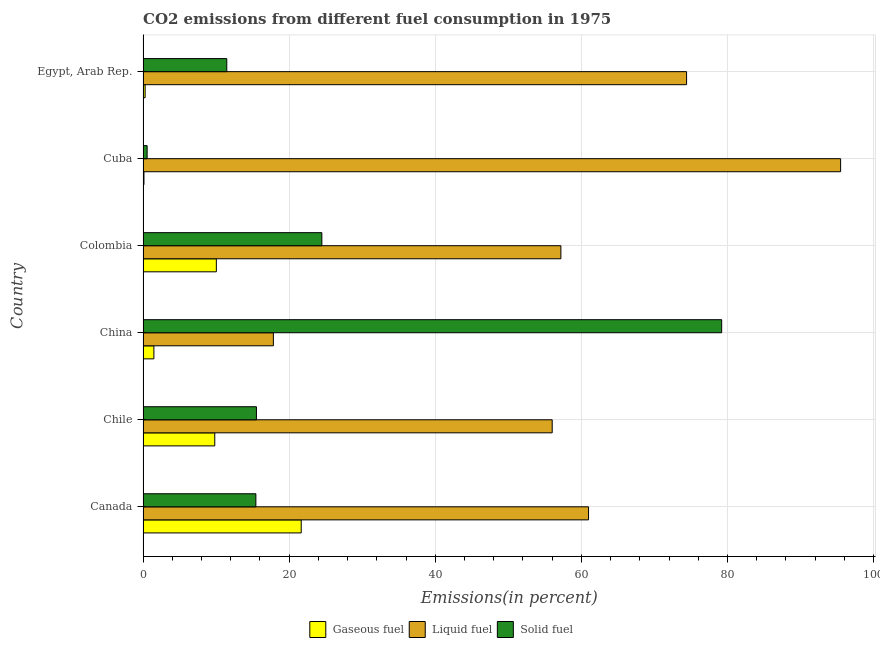How many different coloured bars are there?
Your answer should be compact. 3. How many bars are there on the 4th tick from the top?
Make the answer very short. 3. How many bars are there on the 5th tick from the bottom?
Your answer should be very brief. 3. What is the label of the 5th group of bars from the top?
Keep it short and to the point. Chile. What is the percentage of solid fuel emission in Cuba?
Your answer should be compact. 0.56. Across all countries, what is the maximum percentage of solid fuel emission?
Offer a terse response. 79.21. Across all countries, what is the minimum percentage of solid fuel emission?
Your answer should be compact. 0.56. In which country was the percentage of liquid fuel emission maximum?
Keep it short and to the point. Cuba. What is the total percentage of solid fuel emission in the graph?
Offer a terse response. 146.66. What is the difference between the percentage of liquid fuel emission in Chile and that in Colombia?
Offer a terse response. -1.19. What is the difference between the percentage of liquid fuel emission in Colombia and the percentage of gaseous fuel emission in China?
Your answer should be very brief. 55.71. What is the average percentage of liquid fuel emission per country?
Your answer should be very brief. 60.32. What is the difference between the percentage of gaseous fuel emission and percentage of solid fuel emission in Canada?
Offer a terse response. 6.21. In how many countries, is the percentage of gaseous fuel emission greater than 68 %?
Offer a very short reply. 0. What is the ratio of the percentage of liquid fuel emission in Canada to that in Cuba?
Provide a short and direct response. 0.64. Is the percentage of liquid fuel emission in Canada less than that in Colombia?
Your response must be concise. No. Is the difference between the percentage of gaseous fuel emission in China and Cuba greater than the difference between the percentage of liquid fuel emission in China and Cuba?
Ensure brevity in your answer.  Yes. What is the difference between the highest and the second highest percentage of liquid fuel emission?
Provide a succinct answer. 21.09. What is the difference between the highest and the lowest percentage of liquid fuel emission?
Give a very brief answer. 77.65. Is the sum of the percentage of gaseous fuel emission in Canada and Chile greater than the maximum percentage of solid fuel emission across all countries?
Give a very brief answer. No. What does the 3rd bar from the top in Colombia represents?
Give a very brief answer. Gaseous fuel. What does the 1st bar from the bottom in Chile represents?
Keep it short and to the point. Gaseous fuel. Is it the case that in every country, the sum of the percentage of gaseous fuel emission and percentage of liquid fuel emission is greater than the percentage of solid fuel emission?
Offer a terse response. No. How many countries are there in the graph?
Provide a short and direct response. 6. What is the difference between two consecutive major ticks on the X-axis?
Provide a succinct answer. 20. Are the values on the major ticks of X-axis written in scientific E-notation?
Offer a very short reply. No. Does the graph contain any zero values?
Your response must be concise. No. Does the graph contain grids?
Provide a short and direct response. Yes. How are the legend labels stacked?
Make the answer very short. Horizontal. What is the title of the graph?
Provide a short and direct response. CO2 emissions from different fuel consumption in 1975. What is the label or title of the X-axis?
Make the answer very short. Emissions(in percent). What is the Emissions(in percent) in Gaseous fuel in Canada?
Ensure brevity in your answer.  21.65. What is the Emissions(in percent) of Liquid fuel in Canada?
Offer a terse response. 60.98. What is the Emissions(in percent) of Solid fuel in Canada?
Your response must be concise. 15.44. What is the Emissions(in percent) in Gaseous fuel in Chile?
Make the answer very short. 9.82. What is the Emissions(in percent) in Liquid fuel in Chile?
Make the answer very short. 56.01. What is the Emissions(in percent) of Solid fuel in Chile?
Provide a succinct answer. 15.52. What is the Emissions(in percent) in Gaseous fuel in China?
Your answer should be compact. 1.48. What is the Emissions(in percent) of Liquid fuel in China?
Offer a very short reply. 17.84. What is the Emissions(in percent) of Solid fuel in China?
Provide a short and direct response. 79.21. What is the Emissions(in percent) in Gaseous fuel in Colombia?
Your response must be concise. 10.03. What is the Emissions(in percent) in Liquid fuel in Colombia?
Provide a succinct answer. 57.2. What is the Emissions(in percent) of Solid fuel in Colombia?
Your response must be concise. 24.48. What is the Emissions(in percent) of Gaseous fuel in Cuba?
Provide a short and direct response. 0.12. What is the Emissions(in percent) in Liquid fuel in Cuba?
Provide a succinct answer. 95.49. What is the Emissions(in percent) of Solid fuel in Cuba?
Ensure brevity in your answer.  0.56. What is the Emissions(in percent) in Gaseous fuel in Egypt, Arab Rep.?
Your answer should be very brief. 0.28. What is the Emissions(in percent) in Liquid fuel in Egypt, Arab Rep.?
Ensure brevity in your answer.  74.4. What is the Emissions(in percent) of Solid fuel in Egypt, Arab Rep.?
Your response must be concise. 11.46. Across all countries, what is the maximum Emissions(in percent) in Gaseous fuel?
Provide a succinct answer. 21.65. Across all countries, what is the maximum Emissions(in percent) of Liquid fuel?
Offer a terse response. 95.49. Across all countries, what is the maximum Emissions(in percent) of Solid fuel?
Offer a terse response. 79.21. Across all countries, what is the minimum Emissions(in percent) of Gaseous fuel?
Offer a very short reply. 0.12. Across all countries, what is the minimum Emissions(in percent) of Liquid fuel?
Your response must be concise. 17.84. Across all countries, what is the minimum Emissions(in percent) in Solid fuel?
Make the answer very short. 0.56. What is the total Emissions(in percent) in Gaseous fuel in the graph?
Make the answer very short. 43.38. What is the total Emissions(in percent) of Liquid fuel in the graph?
Your response must be concise. 361.91. What is the total Emissions(in percent) of Solid fuel in the graph?
Offer a terse response. 146.66. What is the difference between the Emissions(in percent) in Gaseous fuel in Canada and that in Chile?
Keep it short and to the point. 11.84. What is the difference between the Emissions(in percent) in Liquid fuel in Canada and that in Chile?
Provide a succinct answer. 4.97. What is the difference between the Emissions(in percent) of Solid fuel in Canada and that in Chile?
Make the answer very short. -0.08. What is the difference between the Emissions(in percent) in Gaseous fuel in Canada and that in China?
Your response must be concise. 20.17. What is the difference between the Emissions(in percent) in Liquid fuel in Canada and that in China?
Your answer should be very brief. 43.14. What is the difference between the Emissions(in percent) in Solid fuel in Canada and that in China?
Ensure brevity in your answer.  -63.76. What is the difference between the Emissions(in percent) of Gaseous fuel in Canada and that in Colombia?
Your answer should be very brief. 11.62. What is the difference between the Emissions(in percent) in Liquid fuel in Canada and that in Colombia?
Offer a very short reply. 3.78. What is the difference between the Emissions(in percent) of Solid fuel in Canada and that in Colombia?
Give a very brief answer. -9.03. What is the difference between the Emissions(in percent) in Gaseous fuel in Canada and that in Cuba?
Give a very brief answer. 21.53. What is the difference between the Emissions(in percent) of Liquid fuel in Canada and that in Cuba?
Offer a terse response. -34.51. What is the difference between the Emissions(in percent) of Solid fuel in Canada and that in Cuba?
Offer a terse response. 14.89. What is the difference between the Emissions(in percent) in Gaseous fuel in Canada and that in Egypt, Arab Rep.?
Give a very brief answer. 21.37. What is the difference between the Emissions(in percent) of Liquid fuel in Canada and that in Egypt, Arab Rep.?
Ensure brevity in your answer.  -13.42. What is the difference between the Emissions(in percent) of Solid fuel in Canada and that in Egypt, Arab Rep.?
Give a very brief answer. 3.98. What is the difference between the Emissions(in percent) of Gaseous fuel in Chile and that in China?
Keep it short and to the point. 8.33. What is the difference between the Emissions(in percent) of Liquid fuel in Chile and that in China?
Make the answer very short. 38.17. What is the difference between the Emissions(in percent) of Solid fuel in Chile and that in China?
Provide a succinct answer. -63.69. What is the difference between the Emissions(in percent) of Gaseous fuel in Chile and that in Colombia?
Keep it short and to the point. -0.22. What is the difference between the Emissions(in percent) of Liquid fuel in Chile and that in Colombia?
Offer a terse response. -1.19. What is the difference between the Emissions(in percent) in Solid fuel in Chile and that in Colombia?
Make the answer very short. -8.96. What is the difference between the Emissions(in percent) in Gaseous fuel in Chile and that in Cuba?
Keep it short and to the point. 9.69. What is the difference between the Emissions(in percent) of Liquid fuel in Chile and that in Cuba?
Your response must be concise. -39.48. What is the difference between the Emissions(in percent) of Solid fuel in Chile and that in Cuba?
Your answer should be very brief. 14.96. What is the difference between the Emissions(in percent) of Gaseous fuel in Chile and that in Egypt, Arab Rep.?
Your answer should be very brief. 9.53. What is the difference between the Emissions(in percent) of Liquid fuel in Chile and that in Egypt, Arab Rep.?
Offer a very short reply. -18.39. What is the difference between the Emissions(in percent) in Solid fuel in Chile and that in Egypt, Arab Rep.?
Offer a very short reply. 4.06. What is the difference between the Emissions(in percent) in Gaseous fuel in China and that in Colombia?
Your answer should be very brief. -8.55. What is the difference between the Emissions(in percent) in Liquid fuel in China and that in Colombia?
Provide a short and direct response. -39.36. What is the difference between the Emissions(in percent) in Solid fuel in China and that in Colombia?
Your response must be concise. 54.73. What is the difference between the Emissions(in percent) of Gaseous fuel in China and that in Cuba?
Your response must be concise. 1.36. What is the difference between the Emissions(in percent) in Liquid fuel in China and that in Cuba?
Your response must be concise. -77.65. What is the difference between the Emissions(in percent) of Solid fuel in China and that in Cuba?
Your answer should be compact. 78.65. What is the difference between the Emissions(in percent) in Gaseous fuel in China and that in Egypt, Arab Rep.?
Provide a short and direct response. 1.2. What is the difference between the Emissions(in percent) of Liquid fuel in China and that in Egypt, Arab Rep.?
Give a very brief answer. -56.56. What is the difference between the Emissions(in percent) in Solid fuel in China and that in Egypt, Arab Rep.?
Make the answer very short. 67.74. What is the difference between the Emissions(in percent) of Gaseous fuel in Colombia and that in Cuba?
Ensure brevity in your answer.  9.91. What is the difference between the Emissions(in percent) of Liquid fuel in Colombia and that in Cuba?
Offer a very short reply. -38.29. What is the difference between the Emissions(in percent) of Solid fuel in Colombia and that in Cuba?
Make the answer very short. 23.92. What is the difference between the Emissions(in percent) in Gaseous fuel in Colombia and that in Egypt, Arab Rep.?
Your answer should be very brief. 9.75. What is the difference between the Emissions(in percent) in Liquid fuel in Colombia and that in Egypt, Arab Rep.?
Offer a very short reply. -17.2. What is the difference between the Emissions(in percent) of Solid fuel in Colombia and that in Egypt, Arab Rep.?
Keep it short and to the point. 13.02. What is the difference between the Emissions(in percent) in Gaseous fuel in Cuba and that in Egypt, Arab Rep.?
Provide a succinct answer. -0.16. What is the difference between the Emissions(in percent) in Liquid fuel in Cuba and that in Egypt, Arab Rep.?
Offer a very short reply. 21.09. What is the difference between the Emissions(in percent) of Solid fuel in Cuba and that in Egypt, Arab Rep.?
Your answer should be very brief. -10.91. What is the difference between the Emissions(in percent) in Gaseous fuel in Canada and the Emissions(in percent) in Liquid fuel in Chile?
Ensure brevity in your answer.  -34.36. What is the difference between the Emissions(in percent) of Gaseous fuel in Canada and the Emissions(in percent) of Solid fuel in Chile?
Ensure brevity in your answer.  6.13. What is the difference between the Emissions(in percent) of Liquid fuel in Canada and the Emissions(in percent) of Solid fuel in Chile?
Offer a very short reply. 45.46. What is the difference between the Emissions(in percent) of Gaseous fuel in Canada and the Emissions(in percent) of Liquid fuel in China?
Your response must be concise. 3.81. What is the difference between the Emissions(in percent) in Gaseous fuel in Canada and the Emissions(in percent) in Solid fuel in China?
Offer a very short reply. -57.55. What is the difference between the Emissions(in percent) in Liquid fuel in Canada and the Emissions(in percent) in Solid fuel in China?
Provide a short and direct response. -18.22. What is the difference between the Emissions(in percent) in Gaseous fuel in Canada and the Emissions(in percent) in Liquid fuel in Colombia?
Your answer should be very brief. -35.55. What is the difference between the Emissions(in percent) of Gaseous fuel in Canada and the Emissions(in percent) of Solid fuel in Colombia?
Provide a short and direct response. -2.83. What is the difference between the Emissions(in percent) of Liquid fuel in Canada and the Emissions(in percent) of Solid fuel in Colombia?
Your response must be concise. 36.5. What is the difference between the Emissions(in percent) in Gaseous fuel in Canada and the Emissions(in percent) in Liquid fuel in Cuba?
Keep it short and to the point. -73.84. What is the difference between the Emissions(in percent) of Gaseous fuel in Canada and the Emissions(in percent) of Solid fuel in Cuba?
Give a very brief answer. 21.1. What is the difference between the Emissions(in percent) in Liquid fuel in Canada and the Emissions(in percent) in Solid fuel in Cuba?
Offer a terse response. 60.43. What is the difference between the Emissions(in percent) of Gaseous fuel in Canada and the Emissions(in percent) of Liquid fuel in Egypt, Arab Rep.?
Provide a short and direct response. -52.75. What is the difference between the Emissions(in percent) of Gaseous fuel in Canada and the Emissions(in percent) of Solid fuel in Egypt, Arab Rep.?
Make the answer very short. 10.19. What is the difference between the Emissions(in percent) of Liquid fuel in Canada and the Emissions(in percent) of Solid fuel in Egypt, Arab Rep.?
Keep it short and to the point. 49.52. What is the difference between the Emissions(in percent) in Gaseous fuel in Chile and the Emissions(in percent) in Liquid fuel in China?
Your answer should be compact. -8.02. What is the difference between the Emissions(in percent) of Gaseous fuel in Chile and the Emissions(in percent) of Solid fuel in China?
Your answer should be compact. -69.39. What is the difference between the Emissions(in percent) in Liquid fuel in Chile and the Emissions(in percent) in Solid fuel in China?
Offer a terse response. -23.2. What is the difference between the Emissions(in percent) in Gaseous fuel in Chile and the Emissions(in percent) in Liquid fuel in Colombia?
Keep it short and to the point. -47.38. What is the difference between the Emissions(in percent) in Gaseous fuel in Chile and the Emissions(in percent) in Solid fuel in Colombia?
Make the answer very short. -14.66. What is the difference between the Emissions(in percent) of Liquid fuel in Chile and the Emissions(in percent) of Solid fuel in Colombia?
Make the answer very short. 31.53. What is the difference between the Emissions(in percent) of Gaseous fuel in Chile and the Emissions(in percent) of Liquid fuel in Cuba?
Ensure brevity in your answer.  -85.67. What is the difference between the Emissions(in percent) of Gaseous fuel in Chile and the Emissions(in percent) of Solid fuel in Cuba?
Provide a short and direct response. 9.26. What is the difference between the Emissions(in percent) in Liquid fuel in Chile and the Emissions(in percent) in Solid fuel in Cuba?
Offer a terse response. 55.45. What is the difference between the Emissions(in percent) in Gaseous fuel in Chile and the Emissions(in percent) in Liquid fuel in Egypt, Arab Rep.?
Ensure brevity in your answer.  -64.59. What is the difference between the Emissions(in percent) of Gaseous fuel in Chile and the Emissions(in percent) of Solid fuel in Egypt, Arab Rep.?
Keep it short and to the point. -1.65. What is the difference between the Emissions(in percent) of Liquid fuel in Chile and the Emissions(in percent) of Solid fuel in Egypt, Arab Rep.?
Provide a short and direct response. 44.55. What is the difference between the Emissions(in percent) of Gaseous fuel in China and the Emissions(in percent) of Liquid fuel in Colombia?
Ensure brevity in your answer.  -55.71. What is the difference between the Emissions(in percent) of Gaseous fuel in China and the Emissions(in percent) of Solid fuel in Colombia?
Keep it short and to the point. -22.99. What is the difference between the Emissions(in percent) in Liquid fuel in China and the Emissions(in percent) in Solid fuel in Colombia?
Make the answer very short. -6.64. What is the difference between the Emissions(in percent) of Gaseous fuel in China and the Emissions(in percent) of Liquid fuel in Cuba?
Your response must be concise. -94.01. What is the difference between the Emissions(in percent) of Gaseous fuel in China and the Emissions(in percent) of Solid fuel in Cuba?
Provide a short and direct response. 0.93. What is the difference between the Emissions(in percent) in Liquid fuel in China and the Emissions(in percent) in Solid fuel in Cuba?
Your answer should be compact. 17.28. What is the difference between the Emissions(in percent) in Gaseous fuel in China and the Emissions(in percent) in Liquid fuel in Egypt, Arab Rep.?
Keep it short and to the point. -72.92. What is the difference between the Emissions(in percent) in Gaseous fuel in China and the Emissions(in percent) in Solid fuel in Egypt, Arab Rep.?
Ensure brevity in your answer.  -9.98. What is the difference between the Emissions(in percent) of Liquid fuel in China and the Emissions(in percent) of Solid fuel in Egypt, Arab Rep.?
Your response must be concise. 6.38. What is the difference between the Emissions(in percent) of Gaseous fuel in Colombia and the Emissions(in percent) of Liquid fuel in Cuba?
Your answer should be very brief. -85.46. What is the difference between the Emissions(in percent) in Gaseous fuel in Colombia and the Emissions(in percent) in Solid fuel in Cuba?
Keep it short and to the point. 9.48. What is the difference between the Emissions(in percent) of Liquid fuel in Colombia and the Emissions(in percent) of Solid fuel in Cuba?
Your answer should be compact. 56.64. What is the difference between the Emissions(in percent) of Gaseous fuel in Colombia and the Emissions(in percent) of Liquid fuel in Egypt, Arab Rep.?
Give a very brief answer. -64.37. What is the difference between the Emissions(in percent) in Gaseous fuel in Colombia and the Emissions(in percent) in Solid fuel in Egypt, Arab Rep.?
Offer a very short reply. -1.43. What is the difference between the Emissions(in percent) of Liquid fuel in Colombia and the Emissions(in percent) of Solid fuel in Egypt, Arab Rep.?
Offer a very short reply. 45.74. What is the difference between the Emissions(in percent) of Gaseous fuel in Cuba and the Emissions(in percent) of Liquid fuel in Egypt, Arab Rep.?
Your answer should be compact. -74.28. What is the difference between the Emissions(in percent) of Gaseous fuel in Cuba and the Emissions(in percent) of Solid fuel in Egypt, Arab Rep.?
Keep it short and to the point. -11.34. What is the difference between the Emissions(in percent) of Liquid fuel in Cuba and the Emissions(in percent) of Solid fuel in Egypt, Arab Rep.?
Your answer should be very brief. 84.03. What is the average Emissions(in percent) of Gaseous fuel per country?
Your response must be concise. 7.23. What is the average Emissions(in percent) in Liquid fuel per country?
Offer a terse response. 60.32. What is the average Emissions(in percent) of Solid fuel per country?
Your response must be concise. 24.44. What is the difference between the Emissions(in percent) of Gaseous fuel and Emissions(in percent) of Liquid fuel in Canada?
Your answer should be compact. -39.33. What is the difference between the Emissions(in percent) of Gaseous fuel and Emissions(in percent) of Solid fuel in Canada?
Offer a terse response. 6.21. What is the difference between the Emissions(in percent) of Liquid fuel and Emissions(in percent) of Solid fuel in Canada?
Your response must be concise. 45.54. What is the difference between the Emissions(in percent) in Gaseous fuel and Emissions(in percent) in Liquid fuel in Chile?
Provide a succinct answer. -46.19. What is the difference between the Emissions(in percent) in Gaseous fuel and Emissions(in percent) in Solid fuel in Chile?
Your answer should be very brief. -5.7. What is the difference between the Emissions(in percent) in Liquid fuel and Emissions(in percent) in Solid fuel in Chile?
Offer a very short reply. 40.49. What is the difference between the Emissions(in percent) of Gaseous fuel and Emissions(in percent) of Liquid fuel in China?
Offer a very short reply. -16.36. What is the difference between the Emissions(in percent) of Gaseous fuel and Emissions(in percent) of Solid fuel in China?
Keep it short and to the point. -77.72. What is the difference between the Emissions(in percent) in Liquid fuel and Emissions(in percent) in Solid fuel in China?
Give a very brief answer. -61.37. What is the difference between the Emissions(in percent) of Gaseous fuel and Emissions(in percent) of Liquid fuel in Colombia?
Keep it short and to the point. -47.17. What is the difference between the Emissions(in percent) in Gaseous fuel and Emissions(in percent) in Solid fuel in Colombia?
Provide a short and direct response. -14.44. What is the difference between the Emissions(in percent) in Liquid fuel and Emissions(in percent) in Solid fuel in Colombia?
Offer a very short reply. 32.72. What is the difference between the Emissions(in percent) in Gaseous fuel and Emissions(in percent) in Liquid fuel in Cuba?
Provide a short and direct response. -95.37. What is the difference between the Emissions(in percent) of Gaseous fuel and Emissions(in percent) of Solid fuel in Cuba?
Give a very brief answer. -0.43. What is the difference between the Emissions(in percent) in Liquid fuel and Emissions(in percent) in Solid fuel in Cuba?
Your response must be concise. 94.93. What is the difference between the Emissions(in percent) of Gaseous fuel and Emissions(in percent) of Liquid fuel in Egypt, Arab Rep.?
Your answer should be very brief. -74.12. What is the difference between the Emissions(in percent) in Gaseous fuel and Emissions(in percent) in Solid fuel in Egypt, Arab Rep.?
Provide a succinct answer. -11.18. What is the difference between the Emissions(in percent) of Liquid fuel and Emissions(in percent) of Solid fuel in Egypt, Arab Rep.?
Make the answer very short. 62.94. What is the ratio of the Emissions(in percent) of Gaseous fuel in Canada to that in Chile?
Make the answer very short. 2.21. What is the ratio of the Emissions(in percent) of Liquid fuel in Canada to that in Chile?
Make the answer very short. 1.09. What is the ratio of the Emissions(in percent) of Solid fuel in Canada to that in Chile?
Offer a terse response. 1. What is the ratio of the Emissions(in percent) of Gaseous fuel in Canada to that in China?
Your response must be concise. 14.6. What is the ratio of the Emissions(in percent) of Liquid fuel in Canada to that in China?
Make the answer very short. 3.42. What is the ratio of the Emissions(in percent) in Solid fuel in Canada to that in China?
Give a very brief answer. 0.2. What is the ratio of the Emissions(in percent) in Gaseous fuel in Canada to that in Colombia?
Keep it short and to the point. 2.16. What is the ratio of the Emissions(in percent) in Liquid fuel in Canada to that in Colombia?
Offer a terse response. 1.07. What is the ratio of the Emissions(in percent) in Solid fuel in Canada to that in Colombia?
Keep it short and to the point. 0.63. What is the ratio of the Emissions(in percent) of Gaseous fuel in Canada to that in Cuba?
Your answer should be very brief. 177.56. What is the ratio of the Emissions(in percent) of Liquid fuel in Canada to that in Cuba?
Offer a terse response. 0.64. What is the ratio of the Emissions(in percent) in Solid fuel in Canada to that in Cuba?
Ensure brevity in your answer.  27.8. What is the ratio of the Emissions(in percent) of Gaseous fuel in Canada to that in Egypt, Arab Rep.?
Provide a short and direct response. 76.51. What is the ratio of the Emissions(in percent) of Liquid fuel in Canada to that in Egypt, Arab Rep.?
Offer a terse response. 0.82. What is the ratio of the Emissions(in percent) in Solid fuel in Canada to that in Egypt, Arab Rep.?
Make the answer very short. 1.35. What is the ratio of the Emissions(in percent) of Gaseous fuel in Chile to that in China?
Your response must be concise. 6.62. What is the ratio of the Emissions(in percent) in Liquid fuel in Chile to that in China?
Provide a succinct answer. 3.14. What is the ratio of the Emissions(in percent) in Solid fuel in Chile to that in China?
Make the answer very short. 0.2. What is the ratio of the Emissions(in percent) in Gaseous fuel in Chile to that in Colombia?
Give a very brief answer. 0.98. What is the ratio of the Emissions(in percent) in Liquid fuel in Chile to that in Colombia?
Give a very brief answer. 0.98. What is the ratio of the Emissions(in percent) of Solid fuel in Chile to that in Colombia?
Your answer should be very brief. 0.63. What is the ratio of the Emissions(in percent) in Gaseous fuel in Chile to that in Cuba?
Offer a terse response. 80.5. What is the ratio of the Emissions(in percent) in Liquid fuel in Chile to that in Cuba?
Offer a terse response. 0.59. What is the ratio of the Emissions(in percent) of Solid fuel in Chile to that in Cuba?
Ensure brevity in your answer.  27.94. What is the ratio of the Emissions(in percent) in Gaseous fuel in Chile to that in Egypt, Arab Rep.?
Your answer should be compact. 34.68. What is the ratio of the Emissions(in percent) in Liquid fuel in Chile to that in Egypt, Arab Rep.?
Your response must be concise. 0.75. What is the ratio of the Emissions(in percent) of Solid fuel in Chile to that in Egypt, Arab Rep.?
Your response must be concise. 1.35. What is the ratio of the Emissions(in percent) of Gaseous fuel in China to that in Colombia?
Provide a short and direct response. 0.15. What is the ratio of the Emissions(in percent) in Liquid fuel in China to that in Colombia?
Provide a short and direct response. 0.31. What is the ratio of the Emissions(in percent) in Solid fuel in China to that in Colombia?
Your answer should be very brief. 3.24. What is the ratio of the Emissions(in percent) in Gaseous fuel in China to that in Cuba?
Provide a short and direct response. 12.16. What is the ratio of the Emissions(in percent) in Liquid fuel in China to that in Cuba?
Give a very brief answer. 0.19. What is the ratio of the Emissions(in percent) of Solid fuel in China to that in Cuba?
Keep it short and to the point. 142.59. What is the ratio of the Emissions(in percent) of Gaseous fuel in China to that in Egypt, Arab Rep.?
Provide a succinct answer. 5.24. What is the ratio of the Emissions(in percent) of Liquid fuel in China to that in Egypt, Arab Rep.?
Offer a very short reply. 0.24. What is the ratio of the Emissions(in percent) in Solid fuel in China to that in Egypt, Arab Rep.?
Your answer should be compact. 6.91. What is the ratio of the Emissions(in percent) of Gaseous fuel in Colombia to that in Cuba?
Your answer should be very brief. 82.27. What is the ratio of the Emissions(in percent) of Liquid fuel in Colombia to that in Cuba?
Provide a short and direct response. 0.6. What is the ratio of the Emissions(in percent) in Solid fuel in Colombia to that in Cuba?
Make the answer very short. 44.06. What is the ratio of the Emissions(in percent) in Gaseous fuel in Colombia to that in Egypt, Arab Rep.?
Your answer should be very brief. 35.45. What is the ratio of the Emissions(in percent) in Liquid fuel in Colombia to that in Egypt, Arab Rep.?
Your response must be concise. 0.77. What is the ratio of the Emissions(in percent) in Solid fuel in Colombia to that in Egypt, Arab Rep.?
Give a very brief answer. 2.14. What is the ratio of the Emissions(in percent) in Gaseous fuel in Cuba to that in Egypt, Arab Rep.?
Your response must be concise. 0.43. What is the ratio of the Emissions(in percent) in Liquid fuel in Cuba to that in Egypt, Arab Rep.?
Offer a very short reply. 1.28. What is the ratio of the Emissions(in percent) of Solid fuel in Cuba to that in Egypt, Arab Rep.?
Make the answer very short. 0.05. What is the difference between the highest and the second highest Emissions(in percent) in Gaseous fuel?
Provide a short and direct response. 11.62. What is the difference between the highest and the second highest Emissions(in percent) of Liquid fuel?
Keep it short and to the point. 21.09. What is the difference between the highest and the second highest Emissions(in percent) in Solid fuel?
Keep it short and to the point. 54.73. What is the difference between the highest and the lowest Emissions(in percent) of Gaseous fuel?
Provide a short and direct response. 21.53. What is the difference between the highest and the lowest Emissions(in percent) of Liquid fuel?
Your answer should be very brief. 77.65. What is the difference between the highest and the lowest Emissions(in percent) of Solid fuel?
Make the answer very short. 78.65. 